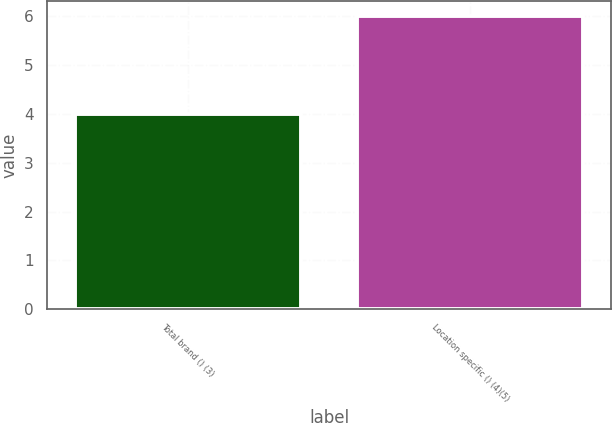Convert chart to OTSL. <chart><loc_0><loc_0><loc_500><loc_500><bar_chart><fcel>Total brand () (3)<fcel>Location specific () (4)(5)<nl><fcel>4<fcel>6<nl></chart> 